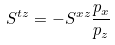Convert formula to latex. <formula><loc_0><loc_0><loc_500><loc_500>S ^ { t z } = - S ^ { x z } \frac { p _ { x } } { p _ { z } }</formula> 